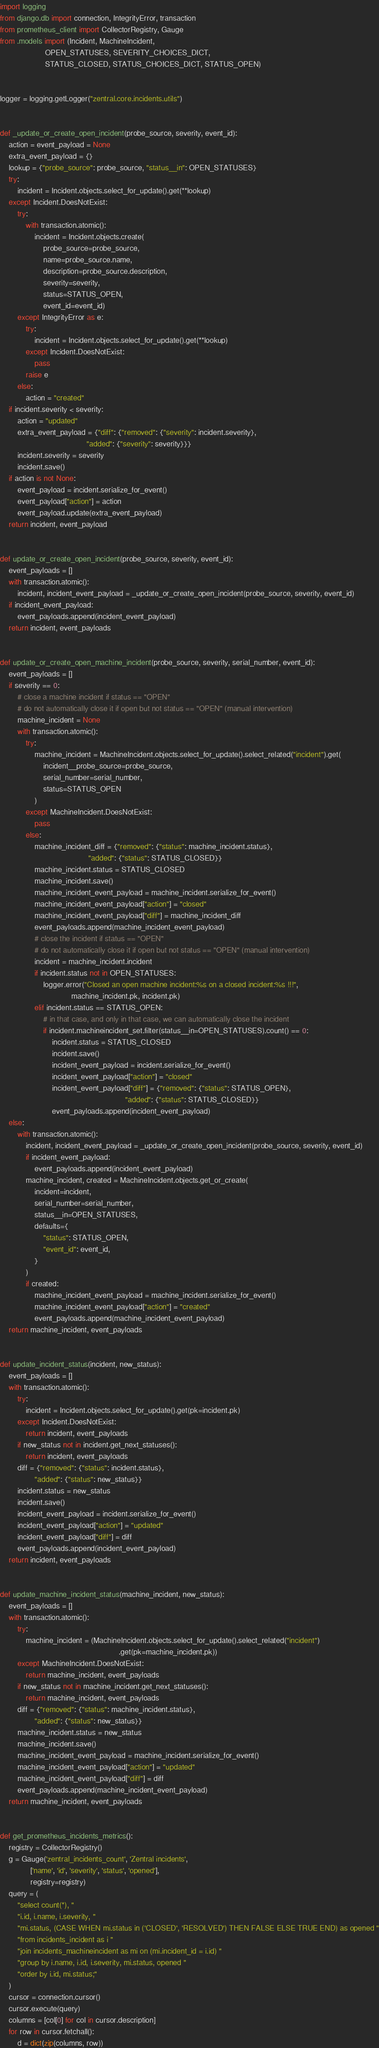<code> <loc_0><loc_0><loc_500><loc_500><_Python_>import logging
from django.db import connection, IntegrityError, transaction
from prometheus_client import CollectorRegistry, Gauge
from .models import (Incident, MachineIncident,
                     OPEN_STATUSES, SEVERITY_CHOICES_DICT,
                     STATUS_CLOSED, STATUS_CHOICES_DICT, STATUS_OPEN)


logger = logging.getLogger("zentral.core.incidents.utils")


def _update_or_create_open_incident(probe_source, severity, event_id):
    action = event_payload = None
    extra_event_payload = {}
    lookup = {"probe_source": probe_source, "status__in": OPEN_STATUSES}
    try:
        incident = Incident.objects.select_for_update().get(**lookup)
    except Incident.DoesNotExist:
        try:
            with transaction.atomic():
                incident = Incident.objects.create(
                    probe_source=probe_source,
                    name=probe_source.name,
                    description=probe_source.description,
                    severity=severity,
                    status=STATUS_OPEN,
                    event_id=event_id)
        except IntegrityError as e:
            try:
                incident = Incident.objects.select_for_update().get(**lookup)
            except Incident.DoesNotExist:
                pass
            raise e
        else:
            action = "created"
    if incident.severity < severity:
        action = "updated"
        extra_event_payload = {"diff": {"removed": {"severity": incident.severity},
                                        "added": {"severity": severity}}}
        incident.severity = severity
        incident.save()
    if action is not None:
        event_payload = incident.serialize_for_event()
        event_payload["action"] = action
        event_payload.update(extra_event_payload)
    return incident, event_payload


def update_or_create_open_incident(probe_source, severity, event_id):
    event_payloads = []
    with transaction.atomic():
        incident, incident_event_payload = _update_or_create_open_incident(probe_source, severity, event_id)
    if incident_event_payload:
        event_payloads.append(incident_event_payload)
    return incident, event_payloads


def update_or_create_open_machine_incident(probe_source, severity, serial_number, event_id):
    event_payloads = []
    if severity == 0:
        # close a machine incident if status == "OPEN"
        # do not automatically close it if open but not status == "OPEN" (manual intervention)
        machine_incident = None
        with transaction.atomic():
            try:
                machine_incident = MachineIncident.objects.select_for_update().select_related("incident").get(
                    incident__probe_source=probe_source,
                    serial_number=serial_number,
                    status=STATUS_OPEN
                )
            except MachineIncident.DoesNotExist:
                pass
            else:
                machine_incident_diff = {"removed": {"status": machine_incident.status},
                                         "added": {"status": STATUS_CLOSED}}
                machine_incident.status = STATUS_CLOSED
                machine_incident.save()
                machine_incident_event_payload = machine_incident.serialize_for_event()
                machine_incident_event_payload["action"] = "closed"
                machine_incident_event_payload["diff"] = machine_incident_diff
                event_payloads.append(machine_incident_event_payload)
                # close the incident if status == "OPEN"
                # do not automatically close it if open but not status == "OPEN" (manual intervention)
                incident = machine_incident.incident
                if incident.status not in OPEN_STATUSES:
                    logger.error("Closed an open machine incident:%s on a closed incident:%s !!!",
                                 machine_incident.pk, incident.pk)
                elif incident.status == STATUS_OPEN:
                    # in that case, and only in that case, we can automatically close the incident
                    if incident.machineincident_set.filter(status__in=OPEN_STATUSES).count() == 0:
                        incident.status = STATUS_CLOSED
                        incident.save()
                        incident_event_payload = incident.serialize_for_event()
                        incident_event_payload["action"] = "closed"
                        incident_event_payload["diff"] = {"removed": {"status": STATUS_OPEN},
                                                          "added": {"status": STATUS_CLOSED}}
                        event_payloads.append(incident_event_payload)
    else:
        with transaction.atomic():
            incident, incident_event_payload = _update_or_create_open_incident(probe_source, severity, event_id)
            if incident_event_payload:
                event_payloads.append(incident_event_payload)
            machine_incident, created = MachineIncident.objects.get_or_create(
                incident=incident,
                serial_number=serial_number,
                status__in=OPEN_STATUSES,
                defaults={
                    "status": STATUS_OPEN,
                    "event_id": event_id,
                }
            )
            if created:
                machine_incident_event_payload = machine_incident.serialize_for_event()
                machine_incident_event_payload["action"] = "created"
                event_payloads.append(machine_incident_event_payload)
    return machine_incident, event_payloads


def update_incident_status(incident, new_status):
    event_payloads = []
    with transaction.atomic():
        try:
            incident = Incident.objects.select_for_update().get(pk=incident.pk)
        except Incident.DoesNotExist:
            return incident, event_payloads
        if new_status not in incident.get_next_statuses():
            return incident, event_payloads
        diff = {"removed": {"status": incident.status},
                "added": {"status": new_status}}
        incident.status = new_status
        incident.save()
        incident_event_payload = incident.serialize_for_event()
        incident_event_payload["action"] = "updated"
        incident_event_payload["diff"] = diff
        event_payloads.append(incident_event_payload)
    return incident, event_payloads


def update_machine_incident_status(machine_incident, new_status):
    event_payloads = []
    with transaction.atomic():
        try:
            machine_incident = (MachineIncident.objects.select_for_update().select_related("incident")
                                                       .get(pk=machine_incident.pk))
        except MachineIncident.DoesNotExist:
            return machine_incident, event_payloads
        if new_status not in machine_incident.get_next_statuses():
            return machine_incident, event_payloads
        diff = {"removed": {"status": machine_incident.status},
                "added": {"status": new_status}}
        machine_incident.status = new_status
        machine_incident.save()
        machine_incident_event_payload = machine_incident.serialize_for_event()
        machine_incident_event_payload["action"] = "updated"
        machine_incident_event_payload["diff"] = diff
        event_payloads.append(machine_incident_event_payload)
    return machine_incident, event_payloads


def get_prometheus_incidents_metrics():
    registry = CollectorRegistry()
    g = Gauge('zentral_incidents_count', 'Zentral incidents',
              ['name', 'id', 'severity', 'status', 'opened'],
              registry=registry)
    query = (
        "select count(*), "
        "i.id, i.name, i.severity, "
        "mi.status, (CASE WHEN mi.status in ('CLOSED', 'RESOLVED') THEN FALSE ELSE TRUE END) as opened "
        "from incidents_incident as i "
        "join incidents_machineincident as mi on (mi.incident_id = i.id) "
        "group by i.name, i.id, i.severity, mi.status, opened "
        "order by i.id, mi.status;"
    )
    cursor = connection.cursor()
    cursor.execute(query)
    columns = [col[0] for col in cursor.description]
    for row in cursor.fetchall():
        d = dict(zip(columns, row))</code> 